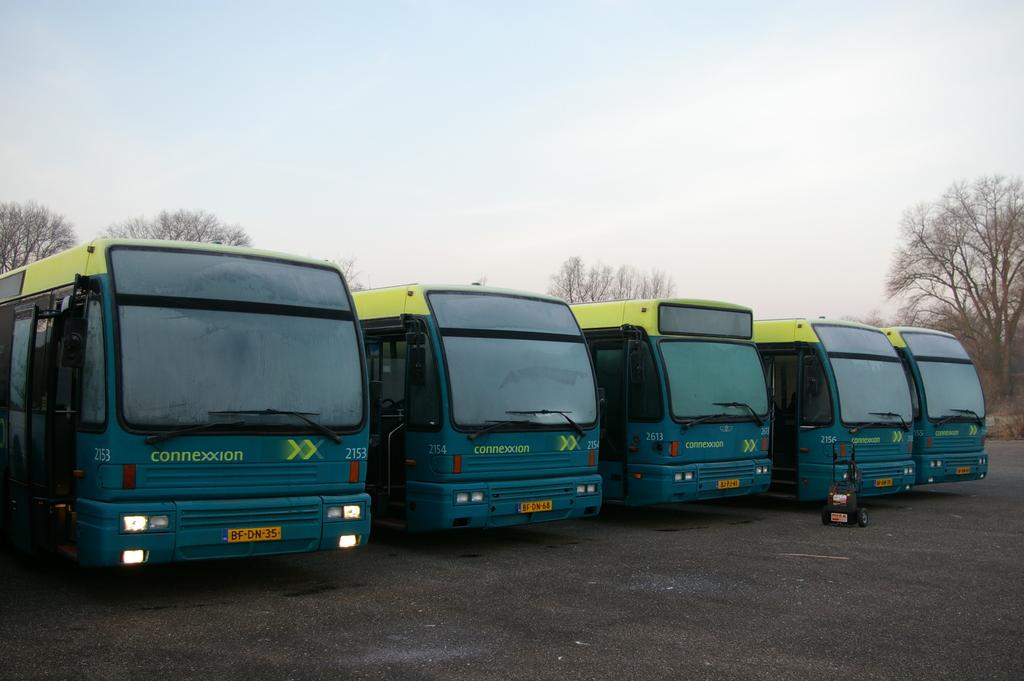How many vehicles are present in the image? There are five vehicles in the image. How are the vehicles arranged in the image? The vehicles are arranged in a row. What features do the vehicles have? The vehicles have headlights and number plates. What can be seen in the background of the image? There are trees visible in the image. What is the setting of the image? There is a road in the image, and the sky is visible. How many babies are sitting on the hoods of the vehicles in the image? There are no babies present in the image; it only features vehicles, trees, a road, and the sky. 